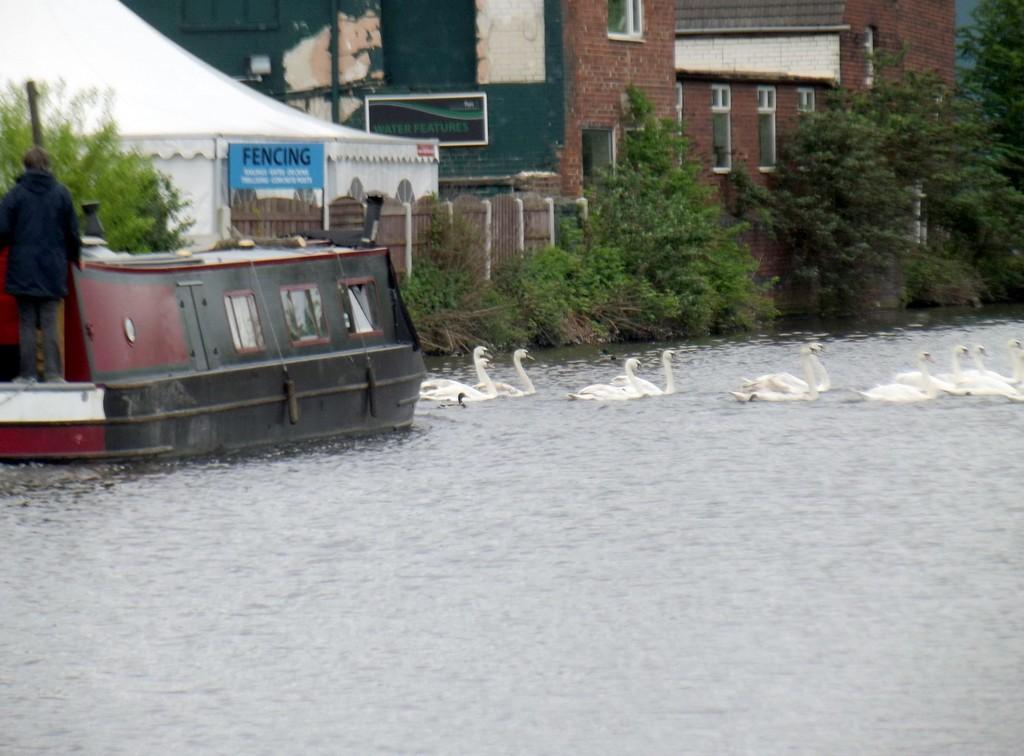Could you give a brief overview of what you see in this image? There is a person standing on boat and we can see swans on the water. Background we can see trees,plants,building and wall 